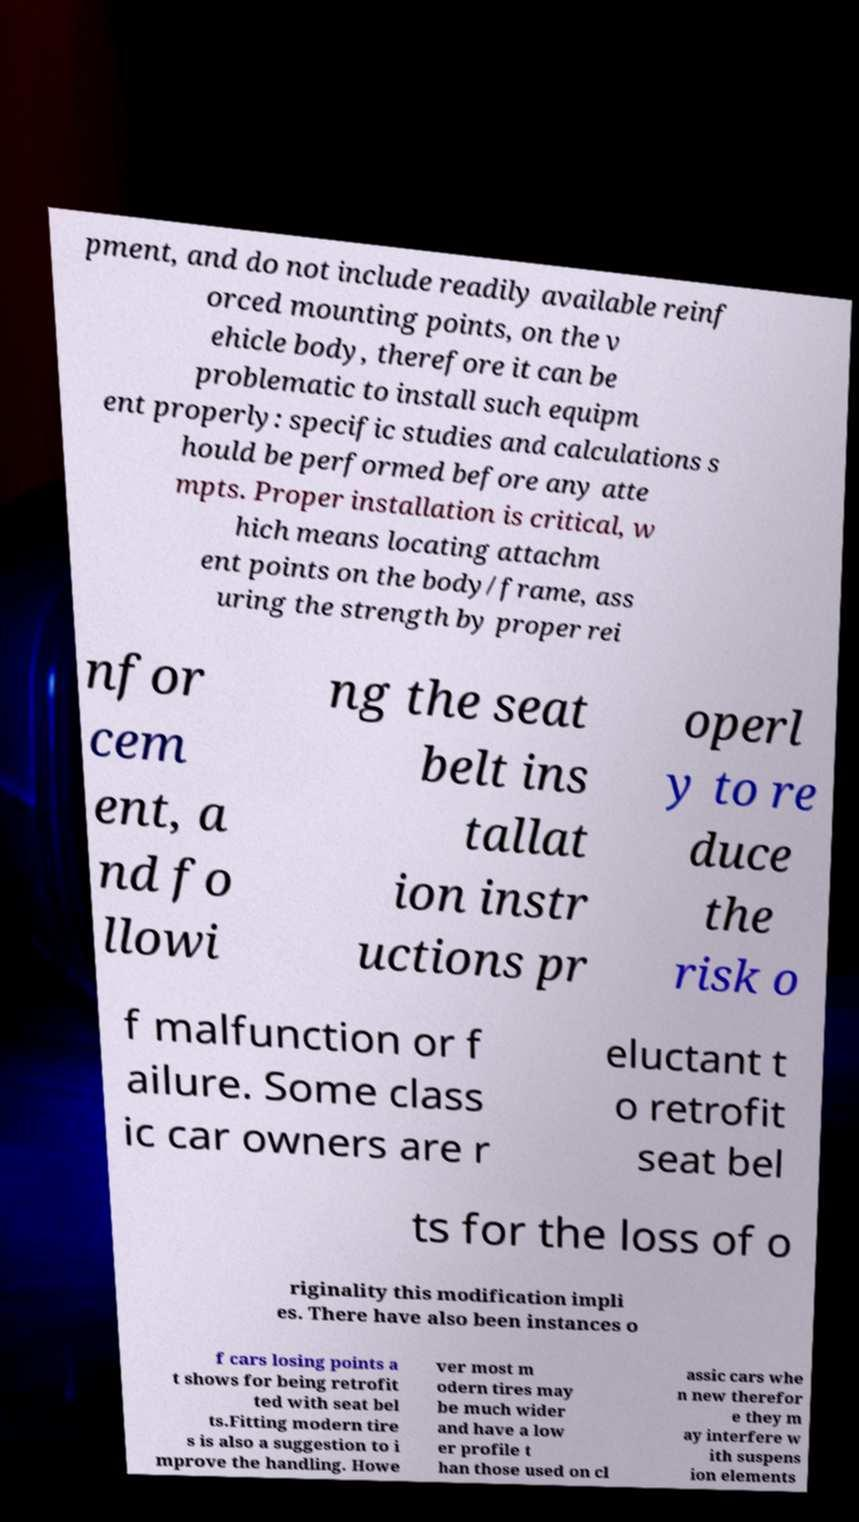Please read and relay the text visible in this image. What does it say? pment, and do not include readily available reinf orced mounting points, on the v ehicle body, therefore it can be problematic to install such equipm ent properly: specific studies and calculations s hould be performed before any atte mpts. Proper installation is critical, w hich means locating attachm ent points on the body/frame, ass uring the strength by proper rei nfor cem ent, a nd fo llowi ng the seat belt ins tallat ion instr uctions pr operl y to re duce the risk o f malfunction or f ailure. Some class ic car owners are r eluctant t o retrofit seat bel ts for the loss of o riginality this modification impli es. There have also been instances o f cars losing points a t shows for being retrofit ted with seat bel ts.Fitting modern tire s is also a suggestion to i mprove the handling. Howe ver most m odern tires may be much wider and have a low er profile t han those used on cl assic cars whe n new therefor e they m ay interfere w ith suspens ion elements 